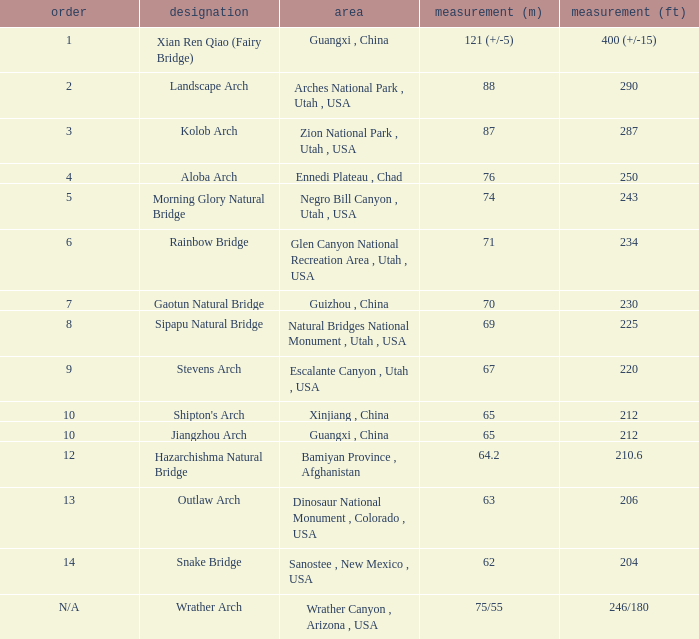What is the rank of the arch with a length in meters of 75/55? N/A. Write the full table. {'header': ['order', 'designation', 'area', 'measurement (m)', 'measurement (ft)'], 'rows': [['1', 'Xian Ren Qiao (Fairy Bridge)', 'Guangxi , China', '121 (+/-5)', '400 (+/-15)'], ['2', 'Landscape Arch', 'Arches National Park , Utah , USA', '88', '290'], ['3', 'Kolob Arch', 'Zion National Park , Utah , USA', '87', '287'], ['4', 'Aloba Arch', 'Ennedi Plateau , Chad', '76', '250'], ['5', 'Morning Glory Natural Bridge', 'Negro Bill Canyon , Utah , USA', '74', '243'], ['6', 'Rainbow Bridge', 'Glen Canyon National Recreation Area , Utah , USA', '71', '234'], ['7', 'Gaotun Natural Bridge', 'Guizhou , China', '70', '230'], ['8', 'Sipapu Natural Bridge', 'Natural Bridges National Monument , Utah , USA', '69', '225'], ['9', 'Stevens Arch', 'Escalante Canyon , Utah , USA', '67', '220'], ['10', "Shipton's Arch", 'Xinjiang , China', '65', '212'], ['10', 'Jiangzhou Arch', 'Guangxi , China', '65', '212'], ['12', 'Hazarchishma Natural Bridge', 'Bamiyan Province , Afghanistan', '64.2', '210.6'], ['13', 'Outlaw Arch', 'Dinosaur National Monument , Colorado , USA', '63', '206'], ['14', 'Snake Bridge', 'Sanostee , New Mexico , USA', '62', '204'], ['N/A', 'Wrather Arch', 'Wrather Canyon , Arizona , USA', '75/55', '246/180']]} 